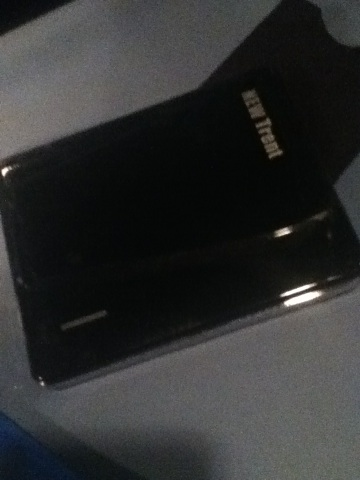This device is capable of hosting vast memories. What creative way could such memories be utilized? Imagine this external hard drive as a digital gallery in an art exhibit. It could host an interactive installation where visitors could access a series of immersive multimedia projects that showcase digital art, historical documentaries, personal stories, and virtual recreations of historical events. Through augmented reality goggles, visitors can explore these memories, interact with them, and gain a deeper understanding and appreciation of the vast narratives encapsulated within this seemingly simple device. 